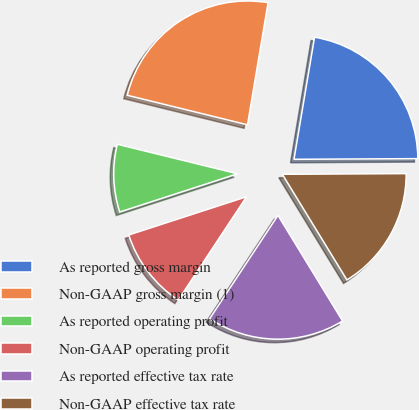<chart> <loc_0><loc_0><loc_500><loc_500><pie_chart><fcel>As reported gross margin<fcel>Non-GAAP gross margin (1)<fcel>As reported operating profit<fcel>Non-GAAP operating profit<fcel>As reported effective tax rate<fcel>Non-GAAP effective tax rate<nl><fcel>22.26%<fcel>23.82%<fcel>8.83%<fcel>10.71%<fcel>18.03%<fcel>16.35%<nl></chart> 